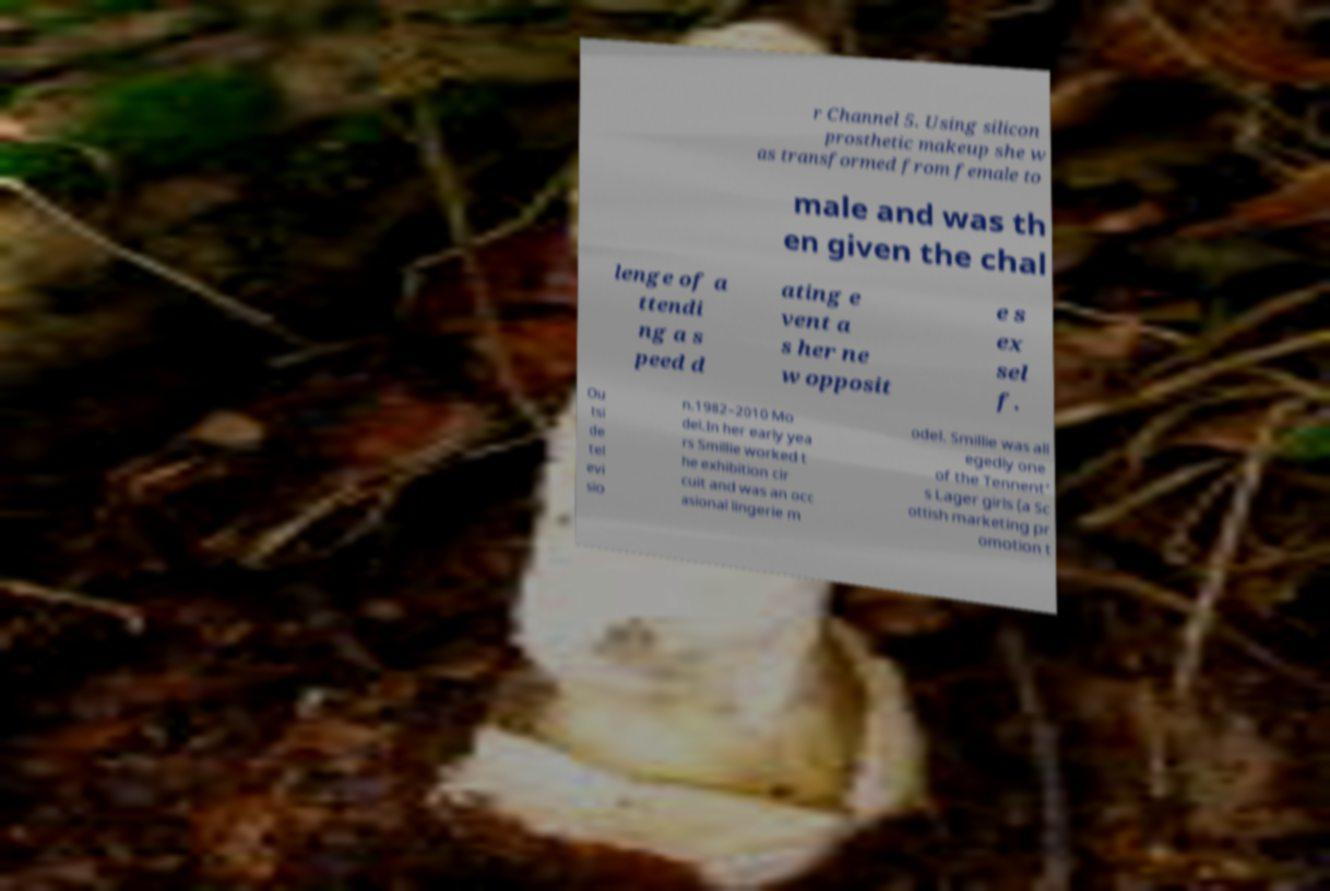I need the written content from this picture converted into text. Can you do that? r Channel 5. Using silicon prosthetic makeup she w as transformed from female to male and was th en given the chal lenge of a ttendi ng a s peed d ating e vent a s her ne w opposit e s ex sel f. Ou tsi de tel evi sio n.1982–2010 Mo del.In her early yea rs Smillie worked t he exhibition cir cuit and was an occ asional lingerie m odel. Smillie was all egedly one of the Tennent' s Lager girls (a Sc ottish marketing pr omotion t 